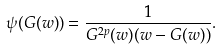<formula> <loc_0><loc_0><loc_500><loc_500>\psi ( G ( w ) ) = \frac { 1 } { G ^ { 2 p } ( w ) ( w - G ( w ) ) } .</formula> 